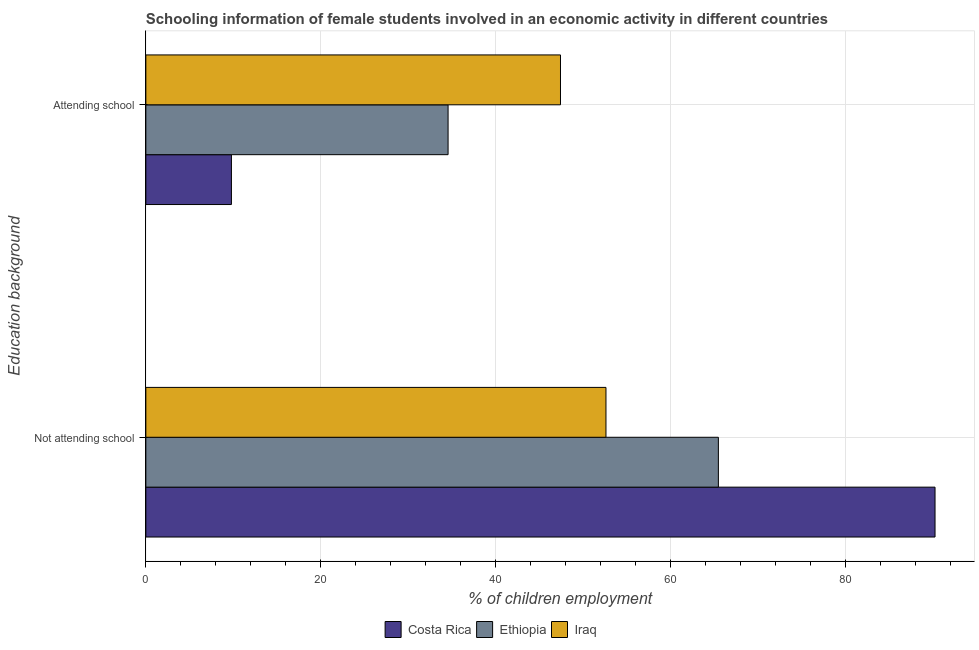How many bars are there on the 1st tick from the top?
Provide a succinct answer. 3. How many bars are there on the 1st tick from the bottom?
Your response must be concise. 3. What is the label of the 2nd group of bars from the top?
Your response must be concise. Not attending school. What is the percentage of employed females who are not attending school in Iraq?
Offer a terse response. 52.6. Across all countries, what is the maximum percentage of employed females who are not attending school?
Give a very brief answer. 90.22. Across all countries, what is the minimum percentage of employed females who are attending school?
Ensure brevity in your answer.  9.78. In which country was the percentage of employed females who are attending school maximum?
Give a very brief answer. Iraq. What is the total percentage of employed females who are attending school in the graph?
Keep it short and to the point. 91.73. What is the difference between the percentage of employed females who are not attending school in Ethiopia and that in Iraq?
Offer a terse response. 12.85. What is the difference between the percentage of employed females who are not attending school in Ethiopia and the percentage of employed females who are attending school in Iraq?
Your response must be concise. 18.05. What is the average percentage of employed females who are not attending school per country?
Your answer should be very brief. 69.42. What is the difference between the percentage of employed females who are not attending school and percentage of employed females who are attending school in Costa Rica?
Keep it short and to the point. 80.43. In how many countries, is the percentage of employed females who are attending school greater than 4 %?
Provide a short and direct response. 3. What is the ratio of the percentage of employed females who are attending school in Ethiopia to that in Costa Rica?
Your answer should be compact. 3.53. Is the percentage of employed females who are not attending school in Ethiopia less than that in Costa Rica?
Give a very brief answer. Yes. What does the 2nd bar from the top in Attending school represents?
Your answer should be compact. Ethiopia. Are all the bars in the graph horizontal?
Provide a short and direct response. Yes. Where does the legend appear in the graph?
Keep it short and to the point. Bottom center. How many legend labels are there?
Provide a succinct answer. 3. How are the legend labels stacked?
Offer a very short reply. Horizontal. What is the title of the graph?
Keep it short and to the point. Schooling information of female students involved in an economic activity in different countries. What is the label or title of the X-axis?
Provide a short and direct response. % of children employment. What is the label or title of the Y-axis?
Your answer should be very brief. Education background. What is the % of children employment in Costa Rica in Not attending school?
Your answer should be very brief. 90.22. What is the % of children employment in Ethiopia in Not attending school?
Your response must be concise. 65.45. What is the % of children employment of Iraq in Not attending school?
Offer a terse response. 52.6. What is the % of children employment in Costa Rica in Attending school?
Your answer should be compact. 9.78. What is the % of children employment in Ethiopia in Attending school?
Your answer should be very brief. 34.55. What is the % of children employment of Iraq in Attending school?
Give a very brief answer. 47.4. Across all Education background, what is the maximum % of children employment of Costa Rica?
Keep it short and to the point. 90.22. Across all Education background, what is the maximum % of children employment in Ethiopia?
Give a very brief answer. 65.45. Across all Education background, what is the maximum % of children employment of Iraq?
Offer a terse response. 52.6. Across all Education background, what is the minimum % of children employment in Costa Rica?
Your answer should be very brief. 9.78. Across all Education background, what is the minimum % of children employment of Ethiopia?
Offer a terse response. 34.55. Across all Education background, what is the minimum % of children employment of Iraq?
Your answer should be compact. 47.4. What is the total % of children employment of Costa Rica in the graph?
Provide a succinct answer. 100. What is the difference between the % of children employment in Costa Rica in Not attending school and that in Attending school?
Your answer should be very brief. 80.43. What is the difference between the % of children employment of Ethiopia in Not attending school and that in Attending school?
Provide a short and direct response. 30.9. What is the difference between the % of children employment of Iraq in Not attending school and that in Attending school?
Your response must be concise. 5.2. What is the difference between the % of children employment in Costa Rica in Not attending school and the % of children employment in Ethiopia in Attending school?
Your answer should be compact. 55.67. What is the difference between the % of children employment in Costa Rica in Not attending school and the % of children employment in Iraq in Attending school?
Offer a very short reply. 42.82. What is the difference between the % of children employment of Ethiopia in Not attending school and the % of children employment of Iraq in Attending school?
Give a very brief answer. 18.05. What is the average % of children employment in Ethiopia per Education background?
Keep it short and to the point. 50. What is the average % of children employment in Iraq per Education background?
Your answer should be compact. 50. What is the difference between the % of children employment of Costa Rica and % of children employment of Ethiopia in Not attending school?
Offer a very short reply. 24.77. What is the difference between the % of children employment in Costa Rica and % of children employment in Iraq in Not attending school?
Your answer should be very brief. 37.62. What is the difference between the % of children employment of Ethiopia and % of children employment of Iraq in Not attending school?
Your answer should be compact. 12.85. What is the difference between the % of children employment in Costa Rica and % of children employment in Ethiopia in Attending school?
Make the answer very short. -24.77. What is the difference between the % of children employment of Costa Rica and % of children employment of Iraq in Attending school?
Ensure brevity in your answer.  -37.62. What is the difference between the % of children employment of Ethiopia and % of children employment of Iraq in Attending school?
Give a very brief answer. -12.85. What is the ratio of the % of children employment in Costa Rica in Not attending school to that in Attending school?
Keep it short and to the point. 9.22. What is the ratio of the % of children employment in Ethiopia in Not attending school to that in Attending school?
Offer a terse response. 1.89. What is the ratio of the % of children employment in Iraq in Not attending school to that in Attending school?
Ensure brevity in your answer.  1.11. What is the difference between the highest and the second highest % of children employment in Costa Rica?
Your response must be concise. 80.43. What is the difference between the highest and the second highest % of children employment in Ethiopia?
Your answer should be compact. 30.9. What is the difference between the highest and the lowest % of children employment in Costa Rica?
Provide a succinct answer. 80.43. What is the difference between the highest and the lowest % of children employment in Ethiopia?
Give a very brief answer. 30.9. 